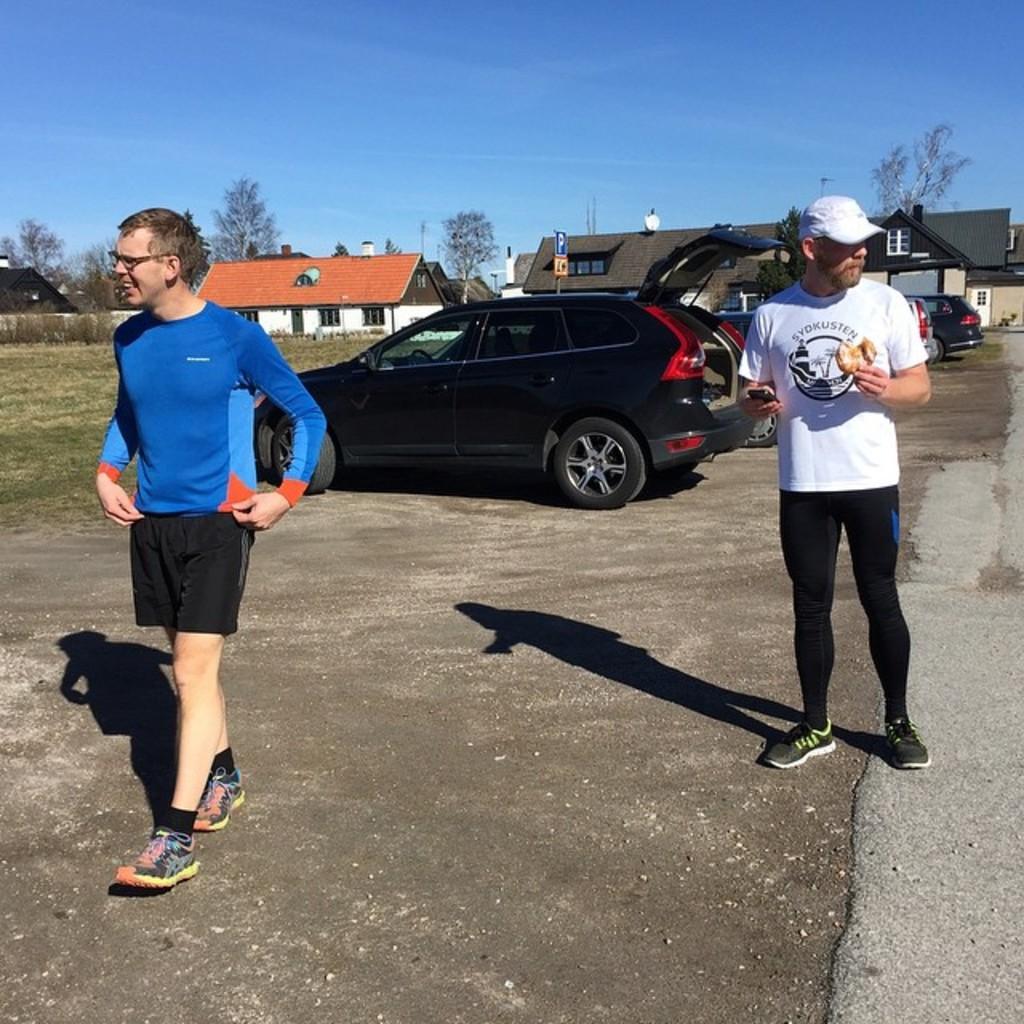In one or two sentences, can you explain what this image depicts? In this picture there are two men on the right and left side of the image and there are cars in the center of the image, there are houses and trees in the background area of the image. 